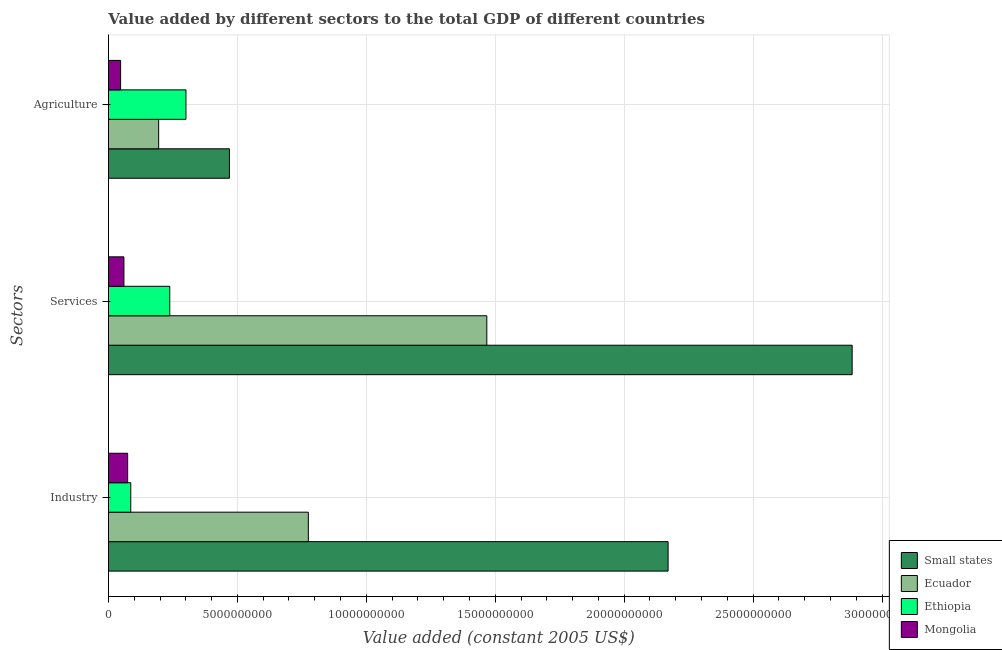How many different coloured bars are there?
Give a very brief answer. 4. Are the number of bars on each tick of the Y-axis equal?
Offer a very short reply. Yes. What is the label of the 1st group of bars from the top?
Your answer should be compact. Agriculture. What is the value added by agricultural sector in Ethiopia?
Ensure brevity in your answer.  3.01e+09. Across all countries, what is the maximum value added by industrial sector?
Your answer should be compact. 2.17e+1. Across all countries, what is the minimum value added by industrial sector?
Your response must be concise. 7.46e+08. In which country was the value added by industrial sector maximum?
Give a very brief answer. Small states. In which country was the value added by services minimum?
Your answer should be very brief. Mongolia. What is the total value added by services in the graph?
Give a very brief answer. 4.65e+1. What is the difference between the value added by services in Ethiopia and that in Ecuador?
Keep it short and to the point. -1.23e+1. What is the difference between the value added by agricultural sector in Ecuador and the value added by industrial sector in Small states?
Give a very brief answer. -1.98e+1. What is the average value added by industrial sector per country?
Offer a terse response. 7.77e+09. What is the difference between the value added by services and value added by agricultural sector in Mongolia?
Make the answer very short. 1.29e+08. What is the ratio of the value added by services in Ecuador to that in Small states?
Keep it short and to the point. 0.51. What is the difference between the highest and the second highest value added by services?
Offer a terse response. 1.42e+1. What is the difference between the highest and the lowest value added by services?
Ensure brevity in your answer.  2.82e+1. What does the 2nd bar from the top in Services represents?
Offer a very short reply. Ethiopia. What does the 3rd bar from the bottom in Services represents?
Offer a very short reply. Ethiopia. Are all the bars in the graph horizontal?
Make the answer very short. Yes. How many countries are there in the graph?
Offer a very short reply. 4. What is the difference between two consecutive major ticks on the X-axis?
Provide a succinct answer. 5.00e+09. Are the values on the major ticks of X-axis written in scientific E-notation?
Give a very brief answer. No. Does the graph contain any zero values?
Provide a short and direct response. No. Does the graph contain grids?
Your response must be concise. Yes. Where does the legend appear in the graph?
Keep it short and to the point. Bottom right. How many legend labels are there?
Your response must be concise. 4. How are the legend labels stacked?
Give a very brief answer. Vertical. What is the title of the graph?
Your response must be concise. Value added by different sectors to the total GDP of different countries. Does "Greece" appear as one of the legend labels in the graph?
Ensure brevity in your answer.  No. What is the label or title of the X-axis?
Make the answer very short. Value added (constant 2005 US$). What is the label or title of the Y-axis?
Ensure brevity in your answer.  Sectors. What is the Value added (constant 2005 US$) in Small states in Industry?
Offer a terse response. 2.17e+1. What is the Value added (constant 2005 US$) in Ecuador in Industry?
Keep it short and to the point. 7.75e+09. What is the Value added (constant 2005 US$) in Ethiopia in Industry?
Make the answer very short. 8.66e+08. What is the Value added (constant 2005 US$) of Mongolia in Industry?
Keep it short and to the point. 7.46e+08. What is the Value added (constant 2005 US$) in Small states in Services?
Your answer should be very brief. 2.88e+1. What is the Value added (constant 2005 US$) of Ecuador in Services?
Your response must be concise. 1.47e+1. What is the Value added (constant 2005 US$) in Ethiopia in Services?
Ensure brevity in your answer.  2.38e+09. What is the Value added (constant 2005 US$) of Mongolia in Services?
Your answer should be very brief. 6.01e+08. What is the Value added (constant 2005 US$) in Small states in Agriculture?
Offer a terse response. 4.69e+09. What is the Value added (constant 2005 US$) of Ecuador in Agriculture?
Give a very brief answer. 1.95e+09. What is the Value added (constant 2005 US$) in Ethiopia in Agriculture?
Keep it short and to the point. 3.01e+09. What is the Value added (constant 2005 US$) in Mongolia in Agriculture?
Give a very brief answer. 4.72e+08. Across all Sectors, what is the maximum Value added (constant 2005 US$) in Small states?
Offer a terse response. 2.88e+1. Across all Sectors, what is the maximum Value added (constant 2005 US$) of Ecuador?
Keep it short and to the point. 1.47e+1. Across all Sectors, what is the maximum Value added (constant 2005 US$) in Ethiopia?
Provide a succinct answer. 3.01e+09. Across all Sectors, what is the maximum Value added (constant 2005 US$) in Mongolia?
Offer a terse response. 7.46e+08. Across all Sectors, what is the minimum Value added (constant 2005 US$) of Small states?
Ensure brevity in your answer.  4.69e+09. Across all Sectors, what is the minimum Value added (constant 2005 US$) in Ecuador?
Your answer should be compact. 1.95e+09. Across all Sectors, what is the minimum Value added (constant 2005 US$) in Ethiopia?
Provide a succinct answer. 8.66e+08. Across all Sectors, what is the minimum Value added (constant 2005 US$) of Mongolia?
Keep it short and to the point. 4.72e+08. What is the total Value added (constant 2005 US$) in Small states in the graph?
Your answer should be compact. 5.52e+1. What is the total Value added (constant 2005 US$) of Ecuador in the graph?
Keep it short and to the point. 2.44e+1. What is the total Value added (constant 2005 US$) of Ethiopia in the graph?
Offer a very short reply. 6.25e+09. What is the total Value added (constant 2005 US$) in Mongolia in the graph?
Your answer should be compact. 1.82e+09. What is the difference between the Value added (constant 2005 US$) of Small states in Industry and that in Services?
Keep it short and to the point. -7.14e+09. What is the difference between the Value added (constant 2005 US$) in Ecuador in Industry and that in Services?
Your response must be concise. -6.92e+09. What is the difference between the Value added (constant 2005 US$) of Ethiopia in Industry and that in Services?
Give a very brief answer. -1.51e+09. What is the difference between the Value added (constant 2005 US$) in Mongolia in Industry and that in Services?
Provide a succinct answer. 1.45e+08. What is the difference between the Value added (constant 2005 US$) in Small states in Industry and that in Agriculture?
Make the answer very short. 1.70e+1. What is the difference between the Value added (constant 2005 US$) of Ecuador in Industry and that in Agriculture?
Keep it short and to the point. 5.80e+09. What is the difference between the Value added (constant 2005 US$) in Ethiopia in Industry and that in Agriculture?
Make the answer very short. -2.14e+09. What is the difference between the Value added (constant 2005 US$) of Mongolia in Industry and that in Agriculture?
Provide a short and direct response. 2.74e+08. What is the difference between the Value added (constant 2005 US$) of Small states in Services and that in Agriculture?
Keep it short and to the point. 2.41e+1. What is the difference between the Value added (constant 2005 US$) of Ecuador in Services and that in Agriculture?
Provide a succinct answer. 1.27e+1. What is the difference between the Value added (constant 2005 US$) of Ethiopia in Services and that in Agriculture?
Ensure brevity in your answer.  -6.28e+08. What is the difference between the Value added (constant 2005 US$) in Mongolia in Services and that in Agriculture?
Give a very brief answer. 1.29e+08. What is the difference between the Value added (constant 2005 US$) in Small states in Industry and the Value added (constant 2005 US$) in Ecuador in Services?
Give a very brief answer. 7.03e+09. What is the difference between the Value added (constant 2005 US$) of Small states in Industry and the Value added (constant 2005 US$) of Ethiopia in Services?
Provide a short and direct response. 1.93e+1. What is the difference between the Value added (constant 2005 US$) of Small states in Industry and the Value added (constant 2005 US$) of Mongolia in Services?
Offer a very short reply. 2.11e+1. What is the difference between the Value added (constant 2005 US$) in Ecuador in Industry and the Value added (constant 2005 US$) in Ethiopia in Services?
Offer a very short reply. 5.37e+09. What is the difference between the Value added (constant 2005 US$) of Ecuador in Industry and the Value added (constant 2005 US$) of Mongolia in Services?
Your answer should be very brief. 7.15e+09. What is the difference between the Value added (constant 2005 US$) of Ethiopia in Industry and the Value added (constant 2005 US$) of Mongolia in Services?
Ensure brevity in your answer.  2.65e+08. What is the difference between the Value added (constant 2005 US$) of Small states in Industry and the Value added (constant 2005 US$) of Ecuador in Agriculture?
Your answer should be compact. 1.98e+1. What is the difference between the Value added (constant 2005 US$) of Small states in Industry and the Value added (constant 2005 US$) of Ethiopia in Agriculture?
Your answer should be very brief. 1.87e+1. What is the difference between the Value added (constant 2005 US$) in Small states in Industry and the Value added (constant 2005 US$) in Mongolia in Agriculture?
Ensure brevity in your answer.  2.12e+1. What is the difference between the Value added (constant 2005 US$) of Ecuador in Industry and the Value added (constant 2005 US$) of Ethiopia in Agriculture?
Your response must be concise. 4.75e+09. What is the difference between the Value added (constant 2005 US$) in Ecuador in Industry and the Value added (constant 2005 US$) in Mongolia in Agriculture?
Provide a succinct answer. 7.28e+09. What is the difference between the Value added (constant 2005 US$) of Ethiopia in Industry and the Value added (constant 2005 US$) of Mongolia in Agriculture?
Give a very brief answer. 3.94e+08. What is the difference between the Value added (constant 2005 US$) in Small states in Services and the Value added (constant 2005 US$) in Ecuador in Agriculture?
Provide a succinct answer. 2.69e+1. What is the difference between the Value added (constant 2005 US$) in Small states in Services and the Value added (constant 2005 US$) in Ethiopia in Agriculture?
Make the answer very short. 2.58e+1. What is the difference between the Value added (constant 2005 US$) of Small states in Services and the Value added (constant 2005 US$) of Mongolia in Agriculture?
Provide a succinct answer. 2.84e+1. What is the difference between the Value added (constant 2005 US$) of Ecuador in Services and the Value added (constant 2005 US$) of Ethiopia in Agriculture?
Provide a short and direct response. 1.17e+1. What is the difference between the Value added (constant 2005 US$) of Ecuador in Services and the Value added (constant 2005 US$) of Mongolia in Agriculture?
Provide a short and direct response. 1.42e+1. What is the difference between the Value added (constant 2005 US$) in Ethiopia in Services and the Value added (constant 2005 US$) in Mongolia in Agriculture?
Your response must be concise. 1.91e+09. What is the average Value added (constant 2005 US$) in Small states per Sectors?
Offer a terse response. 1.84e+1. What is the average Value added (constant 2005 US$) of Ecuador per Sectors?
Keep it short and to the point. 8.12e+09. What is the average Value added (constant 2005 US$) of Ethiopia per Sectors?
Keep it short and to the point. 2.08e+09. What is the average Value added (constant 2005 US$) of Mongolia per Sectors?
Your answer should be very brief. 6.06e+08. What is the difference between the Value added (constant 2005 US$) in Small states and Value added (constant 2005 US$) in Ecuador in Industry?
Your answer should be compact. 1.40e+1. What is the difference between the Value added (constant 2005 US$) in Small states and Value added (constant 2005 US$) in Ethiopia in Industry?
Ensure brevity in your answer.  2.08e+1. What is the difference between the Value added (constant 2005 US$) of Small states and Value added (constant 2005 US$) of Mongolia in Industry?
Make the answer very short. 2.10e+1. What is the difference between the Value added (constant 2005 US$) of Ecuador and Value added (constant 2005 US$) of Ethiopia in Industry?
Offer a very short reply. 6.89e+09. What is the difference between the Value added (constant 2005 US$) in Ecuador and Value added (constant 2005 US$) in Mongolia in Industry?
Your answer should be very brief. 7.01e+09. What is the difference between the Value added (constant 2005 US$) in Ethiopia and Value added (constant 2005 US$) in Mongolia in Industry?
Provide a succinct answer. 1.20e+08. What is the difference between the Value added (constant 2005 US$) in Small states and Value added (constant 2005 US$) in Ecuador in Services?
Ensure brevity in your answer.  1.42e+1. What is the difference between the Value added (constant 2005 US$) of Small states and Value added (constant 2005 US$) of Ethiopia in Services?
Give a very brief answer. 2.65e+1. What is the difference between the Value added (constant 2005 US$) in Small states and Value added (constant 2005 US$) in Mongolia in Services?
Provide a short and direct response. 2.82e+1. What is the difference between the Value added (constant 2005 US$) of Ecuador and Value added (constant 2005 US$) of Ethiopia in Services?
Offer a very short reply. 1.23e+1. What is the difference between the Value added (constant 2005 US$) in Ecuador and Value added (constant 2005 US$) in Mongolia in Services?
Ensure brevity in your answer.  1.41e+1. What is the difference between the Value added (constant 2005 US$) of Ethiopia and Value added (constant 2005 US$) of Mongolia in Services?
Your answer should be very brief. 1.78e+09. What is the difference between the Value added (constant 2005 US$) of Small states and Value added (constant 2005 US$) of Ecuador in Agriculture?
Ensure brevity in your answer.  2.74e+09. What is the difference between the Value added (constant 2005 US$) in Small states and Value added (constant 2005 US$) in Ethiopia in Agriculture?
Provide a short and direct response. 1.69e+09. What is the difference between the Value added (constant 2005 US$) of Small states and Value added (constant 2005 US$) of Mongolia in Agriculture?
Your answer should be compact. 4.22e+09. What is the difference between the Value added (constant 2005 US$) in Ecuador and Value added (constant 2005 US$) in Ethiopia in Agriculture?
Provide a succinct answer. -1.06e+09. What is the difference between the Value added (constant 2005 US$) of Ecuador and Value added (constant 2005 US$) of Mongolia in Agriculture?
Make the answer very short. 1.48e+09. What is the difference between the Value added (constant 2005 US$) of Ethiopia and Value added (constant 2005 US$) of Mongolia in Agriculture?
Provide a succinct answer. 2.53e+09. What is the ratio of the Value added (constant 2005 US$) in Small states in Industry to that in Services?
Give a very brief answer. 0.75. What is the ratio of the Value added (constant 2005 US$) in Ecuador in Industry to that in Services?
Give a very brief answer. 0.53. What is the ratio of the Value added (constant 2005 US$) in Ethiopia in Industry to that in Services?
Your answer should be compact. 0.36. What is the ratio of the Value added (constant 2005 US$) in Mongolia in Industry to that in Services?
Offer a very short reply. 1.24. What is the ratio of the Value added (constant 2005 US$) in Small states in Industry to that in Agriculture?
Your answer should be very brief. 4.63. What is the ratio of the Value added (constant 2005 US$) of Ecuador in Industry to that in Agriculture?
Ensure brevity in your answer.  3.98. What is the ratio of the Value added (constant 2005 US$) of Ethiopia in Industry to that in Agriculture?
Make the answer very short. 0.29. What is the ratio of the Value added (constant 2005 US$) of Mongolia in Industry to that in Agriculture?
Offer a terse response. 1.58. What is the ratio of the Value added (constant 2005 US$) of Small states in Services to that in Agriculture?
Offer a terse response. 6.15. What is the ratio of the Value added (constant 2005 US$) in Ecuador in Services to that in Agriculture?
Your answer should be compact. 7.53. What is the ratio of the Value added (constant 2005 US$) in Ethiopia in Services to that in Agriculture?
Offer a terse response. 0.79. What is the ratio of the Value added (constant 2005 US$) in Mongolia in Services to that in Agriculture?
Make the answer very short. 1.27. What is the difference between the highest and the second highest Value added (constant 2005 US$) in Small states?
Your answer should be very brief. 7.14e+09. What is the difference between the highest and the second highest Value added (constant 2005 US$) of Ecuador?
Your answer should be compact. 6.92e+09. What is the difference between the highest and the second highest Value added (constant 2005 US$) in Ethiopia?
Provide a succinct answer. 6.28e+08. What is the difference between the highest and the second highest Value added (constant 2005 US$) of Mongolia?
Your answer should be compact. 1.45e+08. What is the difference between the highest and the lowest Value added (constant 2005 US$) in Small states?
Offer a terse response. 2.41e+1. What is the difference between the highest and the lowest Value added (constant 2005 US$) of Ecuador?
Offer a very short reply. 1.27e+1. What is the difference between the highest and the lowest Value added (constant 2005 US$) of Ethiopia?
Offer a terse response. 2.14e+09. What is the difference between the highest and the lowest Value added (constant 2005 US$) of Mongolia?
Offer a terse response. 2.74e+08. 